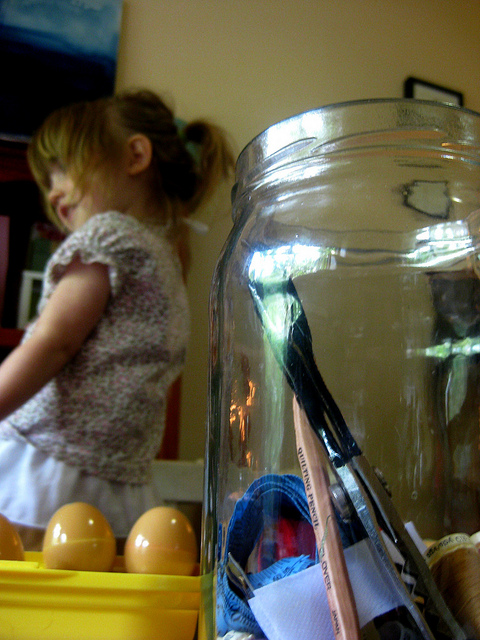Can you guess what the child might be doing or looking at? Without a clear view of the child's actions or facial expression, it's difficult to determine exactly what they are doing. However, the child appears to be engaged with something out of the frame, possibly interacting with another person or playing with toys not visible in the picture. 